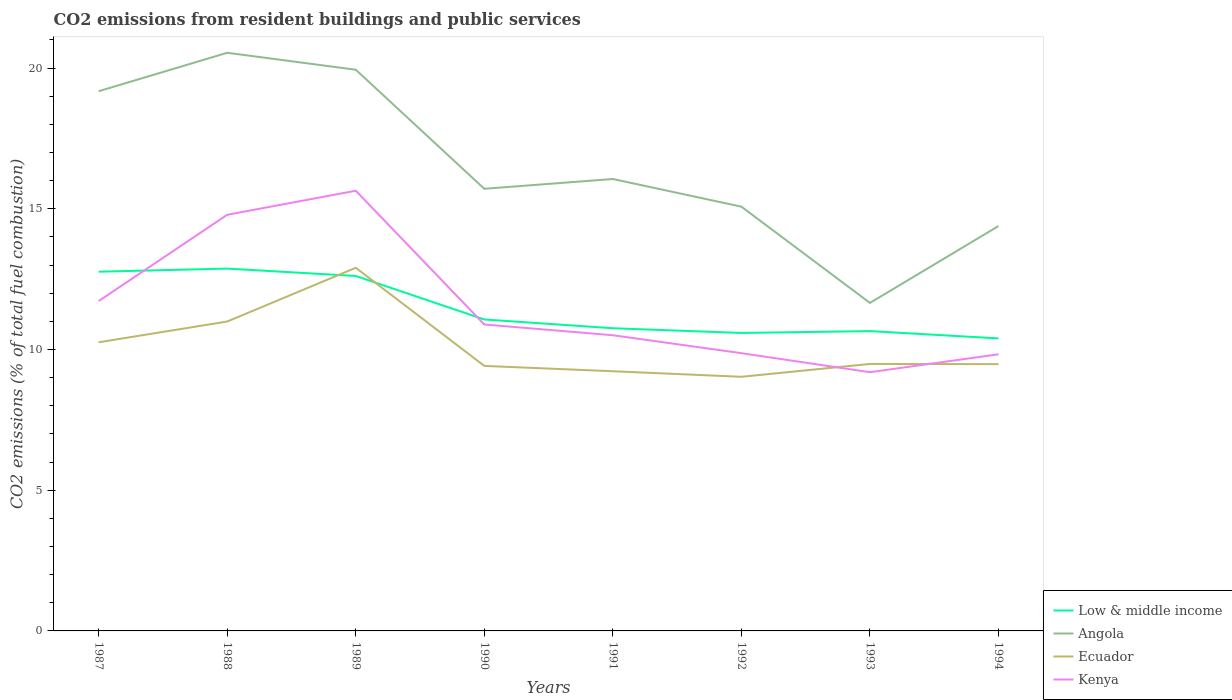How many different coloured lines are there?
Your answer should be compact. 4. Is the number of lines equal to the number of legend labels?
Your answer should be very brief. Yes. Across all years, what is the maximum total CO2 emitted in Low & middle income?
Give a very brief answer. 10.39. In which year was the total CO2 emitted in Kenya maximum?
Provide a succinct answer. 1993. What is the total total CO2 emitted in Kenya in the graph?
Provide a succinct answer. -3.07. What is the difference between the highest and the second highest total CO2 emitted in Kenya?
Your answer should be compact. 6.45. What is the difference between the highest and the lowest total CO2 emitted in Low & middle income?
Offer a very short reply. 3. How many years are there in the graph?
Make the answer very short. 8. What is the difference between two consecutive major ticks on the Y-axis?
Provide a succinct answer. 5. Where does the legend appear in the graph?
Give a very brief answer. Bottom right. What is the title of the graph?
Provide a succinct answer. CO2 emissions from resident buildings and public services. Does "Namibia" appear as one of the legend labels in the graph?
Provide a succinct answer. No. What is the label or title of the Y-axis?
Provide a succinct answer. CO2 emissions (% of total fuel combustion). What is the CO2 emissions (% of total fuel combustion) of Low & middle income in 1987?
Give a very brief answer. 12.76. What is the CO2 emissions (% of total fuel combustion) in Angola in 1987?
Your answer should be very brief. 19.18. What is the CO2 emissions (% of total fuel combustion) in Ecuador in 1987?
Make the answer very short. 10.26. What is the CO2 emissions (% of total fuel combustion) of Kenya in 1987?
Your answer should be compact. 11.72. What is the CO2 emissions (% of total fuel combustion) of Low & middle income in 1988?
Offer a very short reply. 12.88. What is the CO2 emissions (% of total fuel combustion) in Angola in 1988?
Your answer should be very brief. 20.54. What is the CO2 emissions (% of total fuel combustion) in Ecuador in 1988?
Your response must be concise. 10.99. What is the CO2 emissions (% of total fuel combustion) of Kenya in 1988?
Your response must be concise. 14.79. What is the CO2 emissions (% of total fuel combustion) in Low & middle income in 1989?
Your answer should be compact. 12.61. What is the CO2 emissions (% of total fuel combustion) in Angola in 1989?
Offer a terse response. 19.94. What is the CO2 emissions (% of total fuel combustion) of Ecuador in 1989?
Ensure brevity in your answer.  12.9. What is the CO2 emissions (% of total fuel combustion) in Kenya in 1989?
Give a very brief answer. 15.64. What is the CO2 emissions (% of total fuel combustion) of Low & middle income in 1990?
Your response must be concise. 11.07. What is the CO2 emissions (% of total fuel combustion) of Angola in 1990?
Provide a short and direct response. 15.71. What is the CO2 emissions (% of total fuel combustion) of Ecuador in 1990?
Ensure brevity in your answer.  9.42. What is the CO2 emissions (% of total fuel combustion) of Kenya in 1990?
Offer a terse response. 10.89. What is the CO2 emissions (% of total fuel combustion) in Low & middle income in 1991?
Give a very brief answer. 10.76. What is the CO2 emissions (% of total fuel combustion) of Angola in 1991?
Keep it short and to the point. 16.06. What is the CO2 emissions (% of total fuel combustion) in Ecuador in 1991?
Your answer should be very brief. 9.23. What is the CO2 emissions (% of total fuel combustion) of Kenya in 1991?
Give a very brief answer. 10.51. What is the CO2 emissions (% of total fuel combustion) of Low & middle income in 1992?
Keep it short and to the point. 10.59. What is the CO2 emissions (% of total fuel combustion) in Angola in 1992?
Make the answer very short. 15.08. What is the CO2 emissions (% of total fuel combustion) of Ecuador in 1992?
Your response must be concise. 9.03. What is the CO2 emissions (% of total fuel combustion) of Kenya in 1992?
Ensure brevity in your answer.  9.87. What is the CO2 emissions (% of total fuel combustion) of Low & middle income in 1993?
Provide a short and direct response. 10.65. What is the CO2 emissions (% of total fuel combustion) of Angola in 1993?
Ensure brevity in your answer.  11.66. What is the CO2 emissions (% of total fuel combustion) in Ecuador in 1993?
Keep it short and to the point. 9.49. What is the CO2 emissions (% of total fuel combustion) in Kenya in 1993?
Ensure brevity in your answer.  9.19. What is the CO2 emissions (% of total fuel combustion) of Low & middle income in 1994?
Make the answer very short. 10.39. What is the CO2 emissions (% of total fuel combustion) of Angola in 1994?
Offer a terse response. 14.39. What is the CO2 emissions (% of total fuel combustion) of Ecuador in 1994?
Provide a short and direct response. 9.48. What is the CO2 emissions (% of total fuel combustion) in Kenya in 1994?
Offer a very short reply. 9.83. Across all years, what is the maximum CO2 emissions (% of total fuel combustion) in Low & middle income?
Give a very brief answer. 12.88. Across all years, what is the maximum CO2 emissions (% of total fuel combustion) of Angola?
Your answer should be very brief. 20.54. Across all years, what is the maximum CO2 emissions (% of total fuel combustion) of Ecuador?
Your answer should be compact. 12.9. Across all years, what is the maximum CO2 emissions (% of total fuel combustion) in Kenya?
Provide a succinct answer. 15.64. Across all years, what is the minimum CO2 emissions (% of total fuel combustion) of Low & middle income?
Your answer should be very brief. 10.39. Across all years, what is the minimum CO2 emissions (% of total fuel combustion) in Angola?
Offer a terse response. 11.66. Across all years, what is the minimum CO2 emissions (% of total fuel combustion) in Ecuador?
Your answer should be very brief. 9.03. Across all years, what is the minimum CO2 emissions (% of total fuel combustion) in Kenya?
Offer a terse response. 9.19. What is the total CO2 emissions (% of total fuel combustion) of Low & middle income in the graph?
Your answer should be very brief. 91.71. What is the total CO2 emissions (% of total fuel combustion) of Angola in the graph?
Give a very brief answer. 132.55. What is the total CO2 emissions (% of total fuel combustion) of Ecuador in the graph?
Give a very brief answer. 80.8. What is the total CO2 emissions (% of total fuel combustion) in Kenya in the graph?
Give a very brief answer. 92.44. What is the difference between the CO2 emissions (% of total fuel combustion) in Low & middle income in 1987 and that in 1988?
Ensure brevity in your answer.  -0.11. What is the difference between the CO2 emissions (% of total fuel combustion) in Angola in 1987 and that in 1988?
Give a very brief answer. -1.37. What is the difference between the CO2 emissions (% of total fuel combustion) of Ecuador in 1987 and that in 1988?
Make the answer very short. -0.74. What is the difference between the CO2 emissions (% of total fuel combustion) of Kenya in 1987 and that in 1988?
Your answer should be compact. -3.07. What is the difference between the CO2 emissions (% of total fuel combustion) in Low & middle income in 1987 and that in 1989?
Offer a very short reply. 0.15. What is the difference between the CO2 emissions (% of total fuel combustion) in Angola in 1987 and that in 1989?
Ensure brevity in your answer.  -0.76. What is the difference between the CO2 emissions (% of total fuel combustion) of Ecuador in 1987 and that in 1989?
Your answer should be very brief. -2.65. What is the difference between the CO2 emissions (% of total fuel combustion) of Kenya in 1987 and that in 1989?
Ensure brevity in your answer.  -3.92. What is the difference between the CO2 emissions (% of total fuel combustion) in Low & middle income in 1987 and that in 1990?
Give a very brief answer. 1.7. What is the difference between the CO2 emissions (% of total fuel combustion) of Angola in 1987 and that in 1990?
Ensure brevity in your answer.  3.47. What is the difference between the CO2 emissions (% of total fuel combustion) in Ecuador in 1987 and that in 1990?
Give a very brief answer. 0.84. What is the difference between the CO2 emissions (% of total fuel combustion) in Kenya in 1987 and that in 1990?
Keep it short and to the point. 0.83. What is the difference between the CO2 emissions (% of total fuel combustion) of Low & middle income in 1987 and that in 1991?
Give a very brief answer. 2.01. What is the difference between the CO2 emissions (% of total fuel combustion) of Angola in 1987 and that in 1991?
Ensure brevity in your answer.  3.12. What is the difference between the CO2 emissions (% of total fuel combustion) of Ecuador in 1987 and that in 1991?
Keep it short and to the point. 1.03. What is the difference between the CO2 emissions (% of total fuel combustion) in Kenya in 1987 and that in 1991?
Offer a terse response. 1.22. What is the difference between the CO2 emissions (% of total fuel combustion) in Low & middle income in 1987 and that in 1992?
Make the answer very short. 2.18. What is the difference between the CO2 emissions (% of total fuel combustion) of Angola in 1987 and that in 1992?
Your response must be concise. 4.1. What is the difference between the CO2 emissions (% of total fuel combustion) in Ecuador in 1987 and that in 1992?
Your response must be concise. 1.23. What is the difference between the CO2 emissions (% of total fuel combustion) in Kenya in 1987 and that in 1992?
Your response must be concise. 1.85. What is the difference between the CO2 emissions (% of total fuel combustion) in Low & middle income in 1987 and that in 1993?
Your answer should be very brief. 2.11. What is the difference between the CO2 emissions (% of total fuel combustion) in Angola in 1987 and that in 1993?
Offer a very short reply. 7.52. What is the difference between the CO2 emissions (% of total fuel combustion) in Ecuador in 1987 and that in 1993?
Give a very brief answer. 0.77. What is the difference between the CO2 emissions (% of total fuel combustion) in Kenya in 1987 and that in 1993?
Your answer should be compact. 2.53. What is the difference between the CO2 emissions (% of total fuel combustion) of Low & middle income in 1987 and that in 1994?
Offer a terse response. 2.37. What is the difference between the CO2 emissions (% of total fuel combustion) in Angola in 1987 and that in 1994?
Keep it short and to the point. 4.79. What is the difference between the CO2 emissions (% of total fuel combustion) of Ecuador in 1987 and that in 1994?
Offer a very short reply. 0.78. What is the difference between the CO2 emissions (% of total fuel combustion) in Kenya in 1987 and that in 1994?
Offer a terse response. 1.89. What is the difference between the CO2 emissions (% of total fuel combustion) of Low & middle income in 1988 and that in 1989?
Offer a very short reply. 0.26. What is the difference between the CO2 emissions (% of total fuel combustion) of Angola in 1988 and that in 1989?
Offer a terse response. 0.6. What is the difference between the CO2 emissions (% of total fuel combustion) of Ecuador in 1988 and that in 1989?
Keep it short and to the point. -1.91. What is the difference between the CO2 emissions (% of total fuel combustion) in Kenya in 1988 and that in 1989?
Provide a succinct answer. -0.85. What is the difference between the CO2 emissions (% of total fuel combustion) in Low & middle income in 1988 and that in 1990?
Your response must be concise. 1.81. What is the difference between the CO2 emissions (% of total fuel combustion) in Angola in 1988 and that in 1990?
Your answer should be compact. 4.83. What is the difference between the CO2 emissions (% of total fuel combustion) of Ecuador in 1988 and that in 1990?
Your response must be concise. 1.58. What is the difference between the CO2 emissions (% of total fuel combustion) in Kenya in 1988 and that in 1990?
Provide a succinct answer. 3.9. What is the difference between the CO2 emissions (% of total fuel combustion) in Low & middle income in 1988 and that in 1991?
Your answer should be compact. 2.12. What is the difference between the CO2 emissions (% of total fuel combustion) in Angola in 1988 and that in 1991?
Give a very brief answer. 4.49. What is the difference between the CO2 emissions (% of total fuel combustion) in Ecuador in 1988 and that in 1991?
Make the answer very short. 1.77. What is the difference between the CO2 emissions (% of total fuel combustion) of Kenya in 1988 and that in 1991?
Offer a very short reply. 4.28. What is the difference between the CO2 emissions (% of total fuel combustion) of Low & middle income in 1988 and that in 1992?
Provide a short and direct response. 2.29. What is the difference between the CO2 emissions (% of total fuel combustion) in Angola in 1988 and that in 1992?
Make the answer very short. 5.47. What is the difference between the CO2 emissions (% of total fuel combustion) of Ecuador in 1988 and that in 1992?
Your answer should be very brief. 1.96. What is the difference between the CO2 emissions (% of total fuel combustion) in Kenya in 1988 and that in 1992?
Offer a terse response. 4.92. What is the difference between the CO2 emissions (% of total fuel combustion) in Low & middle income in 1988 and that in 1993?
Offer a very short reply. 2.22. What is the difference between the CO2 emissions (% of total fuel combustion) of Angola in 1988 and that in 1993?
Give a very brief answer. 8.89. What is the difference between the CO2 emissions (% of total fuel combustion) of Ecuador in 1988 and that in 1993?
Provide a succinct answer. 1.51. What is the difference between the CO2 emissions (% of total fuel combustion) of Kenya in 1988 and that in 1993?
Your answer should be very brief. 5.59. What is the difference between the CO2 emissions (% of total fuel combustion) of Low & middle income in 1988 and that in 1994?
Offer a very short reply. 2.48. What is the difference between the CO2 emissions (% of total fuel combustion) in Angola in 1988 and that in 1994?
Offer a terse response. 6.16. What is the difference between the CO2 emissions (% of total fuel combustion) in Ecuador in 1988 and that in 1994?
Offer a very short reply. 1.51. What is the difference between the CO2 emissions (% of total fuel combustion) in Kenya in 1988 and that in 1994?
Ensure brevity in your answer.  4.96. What is the difference between the CO2 emissions (% of total fuel combustion) of Low & middle income in 1989 and that in 1990?
Ensure brevity in your answer.  1.55. What is the difference between the CO2 emissions (% of total fuel combustion) in Angola in 1989 and that in 1990?
Your response must be concise. 4.23. What is the difference between the CO2 emissions (% of total fuel combustion) in Ecuador in 1989 and that in 1990?
Keep it short and to the point. 3.49. What is the difference between the CO2 emissions (% of total fuel combustion) in Kenya in 1989 and that in 1990?
Keep it short and to the point. 4.75. What is the difference between the CO2 emissions (% of total fuel combustion) of Low & middle income in 1989 and that in 1991?
Make the answer very short. 1.86. What is the difference between the CO2 emissions (% of total fuel combustion) in Angola in 1989 and that in 1991?
Provide a short and direct response. 3.88. What is the difference between the CO2 emissions (% of total fuel combustion) in Ecuador in 1989 and that in 1991?
Keep it short and to the point. 3.68. What is the difference between the CO2 emissions (% of total fuel combustion) in Kenya in 1989 and that in 1991?
Offer a very short reply. 5.13. What is the difference between the CO2 emissions (% of total fuel combustion) in Low & middle income in 1989 and that in 1992?
Ensure brevity in your answer.  2.02. What is the difference between the CO2 emissions (% of total fuel combustion) in Angola in 1989 and that in 1992?
Your answer should be very brief. 4.87. What is the difference between the CO2 emissions (% of total fuel combustion) of Ecuador in 1989 and that in 1992?
Provide a short and direct response. 3.87. What is the difference between the CO2 emissions (% of total fuel combustion) of Kenya in 1989 and that in 1992?
Provide a succinct answer. 5.77. What is the difference between the CO2 emissions (% of total fuel combustion) in Low & middle income in 1989 and that in 1993?
Your answer should be compact. 1.96. What is the difference between the CO2 emissions (% of total fuel combustion) in Angola in 1989 and that in 1993?
Provide a succinct answer. 8.29. What is the difference between the CO2 emissions (% of total fuel combustion) in Ecuador in 1989 and that in 1993?
Provide a short and direct response. 3.42. What is the difference between the CO2 emissions (% of total fuel combustion) of Kenya in 1989 and that in 1993?
Your answer should be very brief. 6.45. What is the difference between the CO2 emissions (% of total fuel combustion) of Low & middle income in 1989 and that in 1994?
Your answer should be very brief. 2.22. What is the difference between the CO2 emissions (% of total fuel combustion) of Angola in 1989 and that in 1994?
Offer a very short reply. 5.55. What is the difference between the CO2 emissions (% of total fuel combustion) in Ecuador in 1989 and that in 1994?
Keep it short and to the point. 3.42. What is the difference between the CO2 emissions (% of total fuel combustion) in Kenya in 1989 and that in 1994?
Provide a short and direct response. 5.81. What is the difference between the CO2 emissions (% of total fuel combustion) of Low & middle income in 1990 and that in 1991?
Offer a very short reply. 0.31. What is the difference between the CO2 emissions (% of total fuel combustion) in Angola in 1990 and that in 1991?
Ensure brevity in your answer.  -0.35. What is the difference between the CO2 emissions (% of total fuel combustion) of Ecuador in 1990 and that in 1991?
Your response must be concise. 0.19. What is the difference between the CO2 emissions (% of total fuel combustion) of Kenya in 1990 and that in 1991?
Ensure brevity in your answer.  0.38. What is the difference between the CO2 emissions (% of total fuel combustion) in Low & middle income in 1990 and that in 1992?
Your answer should be very brief. 0.48. What is the difference between the CO2 emissions (% of total fuel combustion) of Angola in 1990 and that in 1992?
Your answer should be compact. 0.64. What is the difference between the CO2 emissions (% of total fuel combustion) in Ecuador in 1990 and that in 1992?
Offer a terse response. 0.39. What is the difference between the CO2 emissions (% of total fuel combustion) of Kenya in 1990 and that in 1992?
Offer a terse response. 1.02. What is the difference between the CO2 emissions (% of total fuel combustion) in Low & middle income in 1990 and that in 1993?
Your answer should be very brief. 0.41. What is the difference between the CO2 emissions (% of total fuel combustion) in Angola in 1990 and that in 1993?
Your answer should be very brief. 4.06. What is the difference between the CO2 emissions (% of total fuel combustion) in Ecuador in 1990 and that in 1993?
Your answer should be compact. -0.07. What is the difference between the CO2 emissions (% of total fuel combustion) of Kenya in 1990 and that in 1993?
Your response must be concise. 1.7. What is the difference between the CO2 emissions (% of total fuel combustion) in Low & middle income in 1990 and that in 1994?
Provide a short and direct response. 0.67. What is the difference between the CO2 emissions (% of total fuel combustion) in Angola in 1990 and that in 1994?
Provide a short and direct response. 1.32. What is the difference between the CO2 emissions (% of total fuel combustion) in Ecuador in 1990 and that in 1994?
Provide a short and direct response. -0.06. What is the difference between the CO2 emissions (% of total fuel combustion) of Kenya in 1990 and that in 1994?
Your answer should be compact. 1.06. What is the difference between the CO2 emissions (% of total fuel combustion) in Low & middle income in 1991 and that in 1992?
Provide a short and direct response. 0.17. What is the difference between the CO2 emissions (% of total fuel combustion) in Ecuador in 1991 and that in 1992?
Offer a terse response. 0.2. What is the difference between the CO2 emissions (% of total fuel combustion) of Kenya in 1991 and that in 1992?
Your answer should be compact. 0.64. What is the difference between the CO2 emissions (% of total fuel combustion) in Low & middle income in 1991 and that in 1993?
Give a very brief answer. 0.1. What is the difference between the CO2 emissions (% of total fuel combustion) of Angola in 1991 and that in 1993?
Your answer should be compact. 4.4. What is the difference between the CO2 emissions (% of total fuel combustion) in Ecuador in 1991 and that in 1993?
Your answer should be very brief. -0.26. What is the difference between the CO2 emissions (% of total fuel combustion) in Kenya in 1991 and that in 1993?
Provide a short and direct response. 1.31. What is the difference between the CO2 emissions (% of total fuel combustion) in Low & middle income in 1991 and that in 1994?
Provide a short and direct response. 0.36. What is the difference between the CO2 emissions (% of total fuel combustion) of Angola in 1991 and that in 1994?
Your answer should be compact. 1.67. What is the difference between the CO2 emissions (% of total fuel combustion) of Ecuador in 1991 and that in 1994?
Offer a terse response. -0.25. What is the difference between the CO2 emissions (% of total fuel combustion) in Kenya in 1991 and that in 1994?
Make the answer very short. 0.68. What is the difference between the CO2 emissions (% of total fuel combustion) of Low & middle income in 1992 and that in 1993?
Make the answer very short. -0.07. What is the difference between the CO2 emissions (% of total fuel combustion) in Angola in 1992 and that in 1993?
Keep it short and to the point. 3.42. What is the difference between the CO2 emissions (% of total fuel combustion) of Ecuador in 1992 and that in 1993?
Give a very brief answer. -0.46. What is the difference between the CO2 emissions (% of total fuel combustion) of Kenya in 1992 and that in 1993?
Your answer should be very brief. 0.68. What is the difference between the CO2 emissions (% of total fuel combustion) in Low & middle income in 1992 and that in 1994?
Keep it short and to the point. 0.19. What is the difference between the CO2 emissions (% of total fuel combustion) in Angola in 1992 and that in 1994?
Your response must be concise. 0.69. What is the difference between the CO2 emissions (% of total fuel combustion) in Ecuador in 1992 and that in 1994?
Offer a very short reply. -0.45. What is the difference between the CO2 emissions (% of total fuel combustion) of Kenya in 1992 and that in 1994?
Your answer should be compact. 0.04. What is the difference between the CO2 emissions (% of total fuel combustion) in Low & middle income in 1993 and that in 1994?
Keep it short and to the point. 0.26. What is the difference between the CO2 emissions (% of total fuel combustion) of Angola in 1993 and that in 1994?
Your answer should be compact. -2.73. What is the difference between the CO2 emissions (% of total fuel combustion) in Ecuador in 1993 and that in 1994?
Your answer should be compact. 0.01. What is the difference between the CO2 emissions (% of total fuel combustion) of Kenya in 1993 and that in 1994?
Offer a very short reply. -0.64. What is the difference between the CO2 emissions (% of total fuel combustion) in Low & middle income in 1987 and the CO2 emissions (% of total fuel combustion) in Angola in 1988?
Your response must be concise. -7.78. What is the difference between the CO2 emissions (% of total fuel combustion) of Low & middle income in 1987 and the CO2 emissions (% of total fuel combustion) of Ecuador in 1988?
Your answer should be very brief. 1.77. What is the difference between the CO2 emissions (% of total fuel combustion) in Low & middle income in 1987 and the CO2 emissions (% of total fuel combustion) in Kenya in 1988?
Provide a succinct answer. -2.02. What is the difference between the CO2 emissions (% of total fuel combustion) in Angola in 1987 and the CO2 emissions (% of total fuel combustion) in Ecuador in 1988?
Offer a very short reply. 8.18. What is the difference between the CO2 emissions (% of total fuel combustion) of Angola in 1987 and the CO2 emissions (% of total fuel combustion) of Kenya in 1988?
Provide a short and direct response. 4.39. What is the difference between the CO2 emissions (% of total fuel combustion) in Ecuador in 1987 and the CO2 emissions (% of total fuel combustion) in Kenya in 1988?
Keep it short and to the point. -4.53. What is the difference between the CO2 emissions (% of total fuel combustion) of Low & middle income in 1987 and the CO2 emissions (% of total fuel combustion) of Angola in 1989?
Your answer should be compact. -7.18. What is the difference between the CO2 emissions (% of total fuel combustion) of Low & middle income in 1987 and the CO2 emissions (% of total fuel combustion) of Ecuador in 1989?
Give a very brief answer. -0.14. What is the difference between the CO2 emissions (% of total fuel combustion) in Low & middle income in 1987 and the CO2 emissions (% of total fuel combustion) in Kenya in 1989?
Make the answer very short. -2.88. What is the difference between the CO2 emissions (% of total fuel combustion) in Angola in 1987 and the CO2 emissions (% of total fuel combustion) in Ecuador in 1989?
Ensure brevity in your answer.  6.27. What is the difference between the CO2 emissions (% of total fuel combustion) of Angola in 1987 and the CO2 emissions (% of total fuel combustion) of Kenya in 1989?
Your answer should be very brief. 3.54. What is the difference between the CO2 emissions (% of total fuel combustion) of Ecuador in 1987 and the CO2 emissions (% of total fuel combustion) of Kenya in 1989?
Make the answer very short. -5.39. What is the difference between the CO2 emissions (% of total fuel combustion) of Low & middle income in 1987 and the CO2 emissions (% of total fuel combustion) of Angola in 1990?
Keep it short and to the point. -2.95. What is the difference between the CO2 emissions (% of total fuel combustion) of Low & middle income in 1987 and the CO2 emissions (% of total fuel combustion) of Ecuador in 1990?
Offer a terse response. 3.35. What is the difference between the CO2 emissions (% of total fuel combustion) of Low & middle income in 1987 and the CO2 emissions (% of total fuel combustion) of Kenya in 1990?
Make the answer very short. 1.88. What is the difference between the CO2 emissions (% of total fuel combustion) of Angola in 1987 and the CO2 emissions (% of total fuel combustion) of Ecuador in 1990?
Offer a very short reply. 9.76. What is the difference between the CO2 emissions (% of total fuel combustion) of Angola in 1987 and the CO2 emissions (% of total fuel combustion) of Kenya in 1990?
Provide a short and direct response. 8.29. What is the difference between the CO2 emissions (% of total fuel combustion) in Ecuador in 1987 and the CO2 emissions (% of total fuel combustion) in Kenya in 1990?
Keep it short and to the point. -0.63. What is the difference between the CO2 emissions (% of total fuel combustion) in Low & middle income in 1987 and the CO2 emissions (% of total fuel combustion) in Angola in 1991?
Offer a terse response. -3.29. What is the difference between the CO2 emissions (% of total fuel combustion) in Low & middle income in 1987 and the CO2 emissions (% of total fuel combustion) in Ecuador in 1991?
Offer a very short reply. 3.54. What is the difference between the CO2 emissions (% of total fuel combustion) in Low & middle income in 1987 and the CO2 emissions (% of total fuel combustion) in Kenya in 1991?
Provide a succinct answer. 2.26. What is the difference between the CO2 emissions (% of total fuel combustion) of Angola in 1987 and the CO2 emissions (% of total fuel combustion) of Ecuador in 1991?
Provide a succinct answer. 9.95. What is the difference between the CO2 emissions (% of total fuel combustion) of Angola in 1987 and the CO2 emissions (% of total fuel combustion) of Kenya in 1991?
Keep it short and to the point. 8.67. What is the difference between the CO2 emissions (% of total fuel combustion) of Ecuador in 1987 and the CO2 emissions (% of total fuel combustion) of Kenya in 1991?
Provide a short and direct response. -0.25. What is the difference between the CO2 emissions (% of total fuel combustion) in Low & middle income in 1987 and the CO2 emissions (% of total fuel combustion) in Angola in 1992?
Your answer should be compact. -2.31. What is the difference between the CO2 emissions (% of total fuel combustion) of Low & middle income in 1987 and the CO2 emissions (% of total fuel combustion) of Ecuador in 1992?
Provide a short and direct response. 3.73. What is the difference between the CO2 emissions (% of total fuel combustion) of Low & middle income in 1987 and the CO2 emissions (% of total fuel combustion) of Kenya in 1992?
Your response must be concise. 2.9. What is the difference between the CO2 emissions (% of total fuel combustion) of Angola in 1987 and the CO2 emissions (% of total fuel combustion) of Ecuador in 1992?
Offer a terse response. 10.15. What is the difference between the CO2 emissions (% of total fuel combustion) in Angola in 1987 and the CO2 emissions (% of total fuel combustion) in Kenya in 1992?
Keep it short and to the point. 9.31. What is the difference between the CO2 emissions (% of total fuel combustion) of Ecuador in 1987 and the CO2 emissions (% of total fuel combustion) of Kenya in 1992?
Provide a succinct answer. 0.39. What is the difference between the CO2 emissions (% of total fuel combustion) of Low & middle income in 1987 and the CO2 emissions (% of total fuel combustion) of Angola in 1993?
Provide a short and direct response. 1.11. What is the difference between the CO2 emissions (% of total fuel combustion) in Low & middle income in 1987 and the CO2 emissions (% of total fuel combustion) in Ecuador in 1993?
Your response must be concise. 3.28. What is the difference between the CO2 emissions (% of total fuel combustion) in Low & middle income in 1987 and the CO2 emissions (% of total fuel combustion) in Kenya in 1993?
Offer a terse response. 3.57. What is the difference between the CO2 emissions (% of total fuel combustion) in Angola in 1987 and the CO2 emissions (% of total fuel combustion) in Ecuador in 1993?
Your response must be concise. 9.69. What is the difference between the CO2 emissions (% of total fuel combustion) of Angola in 1987 and the CO2 emissions (% of total fuel combustion) of Kenya in 1993?
Make the answer very short. 9.98. What is the difference between the CO2 emissions (% of total fuel combustion) of Ecuador in 1987 and the CO2 emissions (% of total fuel combustion) of Kenya in 1993?
Offer a terse response. 1.06. What is the difference between the CO2 emissions (% of total fuel combustion) of Low & middle income in 1987 and the CO2 emissions (% of total fuel combustion) of Angola in 1994?
Keep it short and to the point. -1.62. What is the difference between the CO2 emissions (% of total fuel combustion) in Low & middle income in 1987 and the CO2 emissions (% of total fuel combustion) in Ecuador in 1994?
Keep it short and to the point. 3.28. What is the difference between the CO2 emissions (% of total fuel combustion) of Low & middle income in 1987 and the CO2 emissions (% of total fuel combustion) of Kenya in 1994?
Your answer should be compact. 2.93. What is the difference between the CO2 emissions (% of total fuel combustion) in Angola in 1987 and the CO2 emissions (% of total fuel combustion) in Ecuador in 1994?
Your answer should be compact. 9.7. What is the difference between the CO2 emissions (% of total fuel combustion) of Angola in 1987 and the CO2 emissions (% of total fuel combustion) of Kenya in 1994?
Give a very brief answer. 9.35. What is the difference between the CO2 emissions (% of total fuel combustion) of Ecuador in 1987 and the CO2 emissions (% of total fuel combustion) of Kenya in 1994?
Give a very brief answer. 0.43. What is the difference between the CO2 emissions (% of total fuel combustion) of Low & middle income in 1988 and the CO2 emissions (% of total fuel combustion) of Angola in 1989?
Give a very brief answer. -7.07. What is the difference between the CO2 emissions (% of total fuel combustion) of Low & middle income in 1988 and the CO2 emissions (% of total fuel combustion) of Ecuador in 1989?
Keep it short and to the point. -0.03. What is the difference between the CO2 emissions (% of total fuel combustion) of Low & middle income in 1988 and the CO2 emissions (% of total fuel combustion) of Kenya in 1989?
Your response must be concise. -2.77. What is the difference between the CO2 emissions (% of total fuel combustion) in Angola in 1988 and the CO2 emissions (% of total fuel combustion) in Ecuador in 1989?
Your response must be concise. 7.64. What is the difference between the CO2 emissions (% of total fuel combustion) of Angola in 1988 and the CO2 emissions (% of total fuel combustion) of Kenya in 1989?
Your answer should be very brief. 4.9. What is the difference between the CO2 emissions (% of total fuel combustion) of Ecuador in 1988 and the CO2 emissions (% of total fuel combustion) of Kenya in 1989?
Keep it short and to the point. -4.65. What is the difference between the CO2 emissions (% of total fuel combustion) of Low & middle income in 1988 and the CO2 emissions (% of total fuel combustion) of Angola in 1990?
Provide a succinct answer. -2.84. What is the difference between the CO2 emissions (% of total fuel combustion) in Low & middle income in 1988 and the CO2 emissions (% of total fuel combustion) in Ecuador in 1990?
Offer a very short reply. 3.46. What is the difference between the CO2 emissions (% of total fuel combustion) of Low & middle income in 1988 and the CO2 emissions (% of total fuel combustion) of Kenya in 1990?
Provide a succinct answer. 1.99. What is the difference between the CO2 emissions (% of total fuel combustion) in Angola in 1988 and the CO2 emissions (% of total fuel combustion) in Ecuador in 1990?
Provide a short and direct response. 11.13. What is the difference between the CO2 emissions (% of total fuel combustion) in Angola in 1988 and the CO2 emissions (% of total fuel combustion) in Kenya in 1990?
Your answer should be very brief. 9.65. What is the difference between the CO2 emissions (% of total fuel combustion) in Ecuador in 1988 and the CO2 emissions (% of total fuel combustion) in Kenya in 1990?
Your answer should be very brief. 0.1. What is the difference between the CO2 emissions (% of total fuel combustion) of Low & middle income in 1988 and the CO2 emissions (% of total fuel combustion) of Angola in 1991?
Make the answer very short. -3.18. What is the difference between the CO2 emissions (% of total fuel combustion) of Low & middle income in 1988 and the CO2 emissions (% of total fuel combustion) of Ecuador in 1991?
Make the answer very short. 3.65. What is the difference between the CO2 emissions (% of total fuel combustion) of Low & middle income in 1988 and the CO2 emissions (% of total fuel combustion) of Kenya in 1991?
Keep it short and to the point. 2.37. What is the difference between the CO2 emissions (% of total fuel combustion) in Angola in 1988 and the CO2 emissions (% of total fuel combustion) in Ecuador in 1991?
Your answer should be compact. 11.32. What is the difference between the CO2 emissions (% of total fuel combustion) in Angola in 1988 and the CO2 emissions (% of total fuel combustion) in Kenya in 1991?
Give a very brief answer. 10.04. What is the difference between the CO2 emissions (% of total fuel combustion) in Ecuador in 1988 and the CO2 emissions (% of total fuel combustion) in Kenya in 1991?
Make the answer very short. 0.49. What is the difference between the CO2 emissions (% of total fuel combustion) in Low & middle income in 1988 and the CO2 emissions (% of total fuel combustion) in Angola in 1992?
Your answer should be compact. -2.2. What is the difference between the CO2 emissions (% of total fuel combustion) in Low & middle income in 1988 and the CO2 emissions (% of total fuel combustion) in Ecuador in 1992?
Keep it short and to the point. 3.84. What is the difference between the CO2 emissions (% of total fuel combustion) of Low & middle income in 1988 and the CO2 emissions (% of total fuel combustion) of Kenya in 1992?
Offer a terse response. 3.01. What is the difference between the CO2 emissions (% of total fuel combustion) of Angola in 1988 and the CO2 emissions (% of total fuel combustion) of Ecuador in 1992?
Provide a succinct answer. 11.51. What is the difference between the CO2 emissions (% of total fuel combustion) of Angola in 1988 and the CO2 emissions (% of total fuel combustion) of Kenya in 1992?
Your answer should be very brief. 10.67. What is the difference between the CO2 emissions (% of total fuel combustion) of Ecuador in 1988 and the CO2 emissions (% of total fuel combustion) of Kenya in 1992?
Give a very brief answer. 1.12. What is the difference between the CO2 emissions (% of total fuel combustion) of Low & middle income in 1988 and the CO2 emissions (% of total fuel combustion) of Angola in 1993?
Make the answer very short. 1.22. What is the difference between the CO2 emissions (% of total fuel combustion) in Low & middle income in 1988 and the CO2 emissions (% of total fuel combustion) in Ecuador in 1993?
Your answer should be very brief. 3.39. What is the difference between the CO2 emissions (% of total fuel combustion) of Low & middle income in 1988 and the CO2 emissions (% of total fuel combustion) of Kenya in 1993?
Provide a short and direct response. 3.68. What is the difference between the CO2 emissions (% of total fuel combustion) in Angola in 1988 and the CO2 emissions (% of total fuel combustion) in Ecuador in 1993?
Ensure brevity in your answer.  11.06. What is the difference between the CO2 emissions (% of total fuel combustion) of Angola in 1988 and the CO2 emissions (% of total fuel combustion) of Kenya in 1993?
Ensure brevity in your answer.  11.35. What is the difference between the CO2 emissions (% of total fuel combustion) of Ecuador in 1988 and the CO2 emissions (% of total fuel combustion) of Kenya in 1993?
Keep it short and to the point. 1.8. What is the difference between the CO2 emissions (% of total fuel combustion) in Low & middle income in 1988 and the CO2 emissions (% of total fuel combustion) in Angola in 1994?
Ensure brevity in your answer.  -1.51. What is the difference between the CO2 emissions (% of total fuel combustion) of Low & middle income in 1988 and the CO2 emissions (% of total fuel combustion) of Ecuador in 1994?
Give a very brief answer. 3.4. What is the difference between the CO2 emissions (% of total fuel combustion) of Low & middle income in 1988 and the CO2 emissions (% of total fuel combustion) of Kenya in 1994?
Keep it short and to the point. 3.05. What is the difference between the CO2 emissions (% of total fuel combustion) in Angola in 1988 and the CO2 emissions (% of total fuel combustion) in Ecuador in 1994?
Give a very brief answer. 11.06. What is the difference between the CO2 emissions (% of total fuel combustion) of Angola in 1988 and the CO2 emissions (% of total fuel combustion) of Kenya in 1994?
Your response must be concise. 10.71. What is the difference between the CO2 emissions (% of total fuel combustion) in Ecuador in 1988 and the CO2 emissions (% of total fuel combustion) in Kenya in 1994?
Make the answer very short. 1.16. What is the difference between the CO2 emissions (% of total fuel combustion) of Low & middle income in 1989 and the CO2 emissions (% of total fuel combustion) of Angola in 1990?
Your answer should be compact. -3.1. What is the difference between the CO2 emissions (% of total fuel combustion) in Low & middle income in 1989 and the CO2 emissions (% of total fuel combustion) in Ecuador in 1990?
Your answer should be compact. 3.2. What is the difference between the CO2 emissions (% of total fuel combustion) of Low & middle income in 1989 and the CO2 emissions (% of total fuel combustion) of Kenya in 1990?
Provide a succinct answer. 1.72. What is the difference between the CO2 emissions (% of total fuel combustion) in Angola in 1989 and the CO2 emissions (% of total fuel combustion) in Ecuador in 1990?
Your response must be concise. 10.52. What is the difference between the CO2 emissions (% of total fuel combustion) in Angola in 1989 and the CO2 emissions (% of total fuel combustion) in Kenya in 1990?
Make the answer very short. 9.05. What is the difference between the CO2 emissions (% of total fuel combustion) of Ecuador in 1989 and the CO2 emissions (% of total fuel combustion) of Kenya in 1990?
Offer a terse response. 2.01. What is the difference between the CO2 emissions (% of total fuel combustion) in Low & middle income in 1989 and the CO2 emissions (% of total fuel combustion) in Angola in 1991?
Provide a succinct answer. -3.45. What is the difference between the CO2 emissions (% of total fuel combustion) in Low & middle income in 1989 and the CO2 emissions (% of total fuel combustion) in Ecuador in 1991?
Provide a short and direct response. 3.38. What is the difference between the CO2 emissions (% of total fuel combustion) in Low & middle income in 1989 and the CO2 emissions (% of total fuel combustion) in Kenya in 1991?
Keep it short and to the point. 2.11. What is the difference between the CO2 emissions (% of total fuel combustion) in Angola in 1989 and the CO2 emissions (% of total fuel combustion) in Ecuador in 1991?
Your answer should be compact. 10.71. What is the difference between the CO2 emissions (% of total fuel combustion) in Angola in 1989 and the CO2 emissions (% of total fuel combustion) in Kenya in 1991?
Offer a very short reply. 9.43. What is the difference between the CO2 emissions (% of total fuel combustion) in Ecuador in 1989 and the CO2 emissions (% of total fuel combustion) in Kenya in 1991?
Keep it short and to the point. 2.4. What is the difference between the CO2 emissions (% of total fuel combustion) of Low & middle income in 1989 and the CO2 emissions (% of total fuel combustion) of Angola in 1992?
Ensure brevity in your answer.  -2.46. What is the difference between the CO2 emissions (% of total fuel combustion) of Low & middle income in 1989 and the CO2 emissions (% of total fuel combustion) of Ecuador in 1992?
Your response must be concise. 3.58. What is the difference between the CO2 emissions (% of total fuel combustion) of Low & middle income in 1989 and the CO2 emissions (% of total fuel combustion) of Kenya in 1992?
Offer a very short reply. 2.74. What is the difference between the CO2 emissions (% of total fuel combustion) in Angola in 1989 and the CO2 emissions (% of total fuel combustion) in Ecuador in 1992?
Offer a very short reply. 10.91. What is the difference between the CO2 emissions (% of total fuel combustion) in Angola in 1989 and the CO2 emissions (% of total fuel combustion) in Kenya in 1992?
Give a very brief answer. 10.07. What is the difference between the CO2 emissions (% of total fuel combustion) in Ecuador in 1989 and the CO2 emissions (% of total fuel combustion) in Kenya in 1992?
Offer a very short reply. 3.03. What is the difference between the CO2 emissions (% of total fuel combustion) of Low & middle income in 1989 and the CO2 emissions (% of total fuel combustion) of Angola in 1993?
Your answer should be compact. 0.96. What is the difference between the CO2 emissions (% of total fuel combustion) of Low & middle income in 1989 and the CO2 emissions (% of total fuel combustion) of Ecuador in 1993?
Make the answer very short. 3.13. What is the difference between the CO2 emissions (% of total fuel combustion) of Low & middle income in 1989 and the CO2 emissions (% of total fuel combustion) of Kenya in 1993?
Make the answer very short. 3.42. What is the difference between the CO2 emissions (% of total fuel combustion) of Angola in 1989 and the CO2 emissions (% of total fuel combustion) of Ecuador in 1993?
Provide a short and direct response. 10.45. What is the difference between the CO2 emissions (% of total fuel combustion) of Angola in 1989 and the CO2 emissions (% of total fuel combustion) of Kenya in 1993?
Make the answer very short. 10.75. What is the difference between the CO2 emissions (% of total fuel combustion) of Ecuador in 1989 and the CO2 emissions (% of total fuel combustion) of Kenya in 1993?
Your response must be concise. 3.71. What is the difference between the CO2 emissions (% of total fuel combustion) of Low & middle income in 1989 and the CO2 emissions (% of total fuel combustion) of Angola in 1994?
Provide a short and direct response. -1.77. What is the difference between the CO2 emissions (% of total fuel combustion) in Low & middle income in 1989 and the CO2 emissions (% of total fuel combustion) in Ecuador in 1994?
Provide a succinct answer. 3.13. What is the difference between the CO2 emissions (% of total fuel combustion) of Low & middle income in 1989 and the CO2 emissions (% of total fuel combustion) of Kenya in 1994?
Make the answer very short. 2.78. What is the difference between the CO2 emissions (% of total fuel combustion) in Angola in 1989 and the CO2 emissions (% of total fuel combustion) in Ecuador in 1994?
Your answer should be very brief. 10.46. What is the difference between the CO2 emissions (% of total fuel combustion) of Angola in 1989 and the CO2 emissions (% of total fuel combustion) of Kenya in 1994?
Your response must be concise. 10.11. What is the difference between the CO2 emissions (% of total fuel combustion) in Ecuador in 1989 and the CO2 emissions (% of total fuel combustion) in Kenya in 1994?
Provide a short and direct response. 3.07. What is the difference between the CO2 emissions (% of total fuel combustion) of Low & middle income in 1990 and the CO2 emissions (% of total fuel combustion) of Angola in 1991?
Your answer should be compact. -4.99. What is the difference between the CO2 emissions (% of total fuel combustion) in Low & middle income in 1990 and the CO2 emissions (% of total fuel combustion) in Ecuador in 1991?
Your response must be concise. 1.84. What is the difference between the CO2 emissions (% of total fuel combustion) in Low & middle income in 1990 and the CO2 emissions (% of total fuel combustion) in Kenya in 1991?
Ensure brevity in your answer.  0.56. What is the difference between the CO2 emissions (% of total fuel combustion) of Angola in 1990 and the CO2 emissions (% of total fuel combustion) of Ecuador in 1991?
Offer a very short reply. 6.48. What is the difference between the CO2 emissions (% of total fuel combustion) of Angola in 1990 and the CO2 emissions (% of total fuel combustion) of Kenya in 1991?
Offer a very short reply. 5.2. What is the difference between the CO2 emissions (% of total fuel combustion) in Ecuador in 1990 and the CO2 emissions (% of total fuel combustion) in Kenya in 1991?
Your answer should be compact. -1.09. What is the difference between the CO2 emissions (% of total fuel combustion) of Low & middle income in 1990 and the CO2 emissions (% of total fuel combustion) of Angola in 1992?
Offer a terse response. -4.01. What is the difference between the CO2 emissions (% of total fuel combustion) in Low & middle income in 1990 and the CO2 emissions (% of total fuel combustion) in Ecuador in 1992?
Your answer should be very brief. 2.04. What is the difference between the CO2 emissions (% of total fuel combustion) of Low & middle income in 1990 and the CO2 emissions (% of total fuel combustion) of Kenya in 1992?
Provide a short and direct response. 1.2. What is the difference between the CO2 emissions (% of total fuel combustion) in Angola in 1990 and the CO2 emissions (% of total fuel combustion) in Ecuador in 1992?
Offer a terse response. 6.68. What is the difference between the CO2 emissions (% of total fuel combustion) of Angola in 1990 and the CO2 emissions (% of total fuel combustion) of Kenya in 1992?
Your answer should be very brief. 5.84. What is the difference between the CO2 emissions (% of total fuel combustion) of Ecuador in 1990 and the CO2 emissions (% of total fuel combustion) of Kenya in 1992?
Provide a succinct answer. -0.45. What is the difference between the CO2 emissions (% of total fuel combustion) of Low & middle income in 1990 and the CO2 emissions (% of total fuel combustion) of Angola in 1993?
Your answer should be compact. -0.59. What is the difference between the CO2 emissions (% of total fuel combustion) in Low & middle income in 1990 and the CO2 emissions (% of total fuel combustion) in Ecuador in 1993?
Provide a short and direct response. 1.58. What is the difference between the CO2 emissions (% of total fuel combustion) in Low & middle income in 1990 and the CO2 emissions (% of total fuel combustion) in Kenya in 1993?
Make the answer very short. 1.87. What is the difference between the CO2 emissions (% of total fuel combustion) of Angola in 1990 and the CO2 emissions (% of total fuel combustion) of Ecuador in 1993?
Keep it short and to the point. 6.22. What is the difference between the CO2 emissions (% of total fuel combustion) in Angola in 1990 and the CO2 emissions (% of total fuel combustion) in Kenya in 1993?
Provide a succinct answer. 6.52. What is the difference between the CO2 emissions (% of total fuel combustion) of Ecuador in 1990 and the CO2 emissions (% of total fuel combustion) of Kenya in 1993?
Make the answer very short. 0.22. What is the difference between the CO2 emissions (% of total fuel combustion) of Low & middle income in 1990 and the CO2 emissions (% of total fuel combustion) of Angola in 1994?
Offer a terse response. -3.32. What is the difference between the CO2 emissions (% of total fuel combustion) in Low & middle income in 1990 and the CO2 emissions (% of total fuel combustion) in Ecuador in 1994?
Provide a short and direct response. 1.59. What is the difference between the CO2 emissions (% of total fuel combustion) in Low & middle income in 1990 and the CO2 emissions (% of total fuel combustion) in Kenya in 1994?
Your answer should be compact. 1.24. What is the difference between the CO2 emissions (% of total fuel combustion) in Angola in 1990 and the CO2 emissions (% of total fuel combustion) in Ecuador in 1994?
Offer a very short reply. 6.23. What is the difference between the CO2 emissions (% of total fuel combustion) in Angola in 1990 and the CO2 emissions (% of total fuel combustion) in Kenya in 1994?
Your answer should be compact. 5.88. What is the difference between the CO2 emissions (% of total fuel combustion) of Ecuador in 1990 and the CO2 emissions (% of total fuel combustion) of Kenya in 1994?
Provide a succinct answer. -0.41. What is the difference between the CO2 emissions (% of total fuel combustion) of Low & middle income in 1991 and the CO2 emissions (% of total fuel combustion) of Angola in 1992?
Keep it short and to the point. -4.32. What is the difference between the CO2 emissions (% of total fuel combustion) of Low & middle income in 1991 and the CO2 emissions (% of total fuel combustion) of Ecuador in 1992?
Keep it short and to the point. 1.73. What is the difference between the CO2 emissions (% of total fuel combustion) of Low & middle income in 1991 and the CO2 emissions (% of total fuel combustion) of Kenya in 1992?
Offer a terse response. 0.89. What is the difference between the CO2 emissions (% of total fuel combustion) of Angola in 1991 and the CO2 emissions (% of total fuel combustion) of Ecuador in 1992?
Offer a terse response. 7.03. What is the difference between the CO2 emissions (% of total fuel combustion) of Angola in 1991 and the CO2 emissions (% of total fuel combustion) of Kenya in 1992?
Provide a short and direct response. 6.19. What is the difference between the CO2 emissions (% of total fuel combustion) in Ecuador in 1991 and the CO2 emissions (% of total fuel combustion) in Kenya in 1992?
Your response must be concise. -0.64. What is the difference between the CO2 emissions (% of total fuel combustion) in Low & middle income in 1991 and the CO2 emissions (% of total fuel combustion) in Angola in 1993?
Provide a succinct answer. -0.9. What is the difference between the CO2 emissions (% of total fuel combustion) of Low & middle income in 1991 and the CO2 emissions (% of total fuel combustion) of Ecuador in 1993?
Make the answer very short. 1.27. What is the difference between the CO2 emissions (% of total fuel combustion) of Low & middle income in 1991 and the CO2 emissions (% of total fuel combustion) of Kenya in 1993?
Ensure brevity in your answer.  1.56. What is the difference between the CO2 emissions (% of total fuel combustion) of Angola in 1991 and the CO2 emissions (% of total fuel combustion) of Ecuador in 1993?
Give a very brief answer. 6.57. What is the difference between the CO2 emissions (% of total fuel combustion) of Angola in 1991 and the CO2 emissions (% of total fuel combustion) of Kenya in 1993?
Your answer should be compact. 6.87. What is the difference between the CO2 emissions (% of total fuel combustion) in Ecuador in 1991 and the CO2 emissions (% of total fuel combustion) in Kenya in 1993?
Your answer should be compact. 0.03. What is the difference between the CO2 emissions (% of total fuel combustion) of Low & middle income in 1991 and the CO2 emissions (% of total fuel combustion) of Angola in 1994?
Provide a succinct answer. -3.63. What is the difference between the CO2 emissions (% of total fuel combustion) of Low & middle income in 1991 and the CO2 emissions (% of total fuel combustion) of Ecuador in 1994?
Ensure brevity in your answer.  1.28. What is the difference between the CO2 emissions (% of total fuel combustion) in Low & middle income in 1991 and the CO2 emissions (% of total fuel combustion) in Kenya in 1994?
Keep it short and to the point. 0.93. What is the difference between the CO2 emissions (% of total fuel combustion) of Angola in 1991 and the CO2 emissions (% of total fuel combustion) of Ecuador in 1994?
Keep it short and to the point. 6.58. What is the difference between the CO2 emissions (% of total fuel combustion) in Angola in 1991 and the CO2 emissions (% of total fuel combustion) in Kenya in 1994?
Provide a succinct answer. 6.23. What is the difference between the CO2 emissions (% of total fuel combustion) in Ecuador in 1991 and the CO2 emissions (% of total fuel combustion) in Kenya in 1994?
Your response must be concise. -0.6. What is the difference between the CO2 emissions (% of total fuel combustion) in Low & middle income in 1992 and the CO2 emissions (% of total fuel combustion) in Angola in 1993?
Ensure brevity in your answer.  -1.07. What is the difference between the CO2 emissions (% of total fuel combustion) of Low & middle income in 1992 and the CO2 emissions (% of total fuel combustion) of Ecuador in 1993?
Your answer should be very brief. 1.1. What is the difference between the CO2 emissions (% of total fuel combustion) of Low & middle income in 1992 and the CO2 emissions (% of total fuel combustion) of Kenya in 1993?
Ensure brevity in your answer.  1.39. What is the difference between the CO2 emissions (% of total fuel combustion) of Angola in 1992 and the CO2 emissions (% of total fuel combustion) of Ecuador in 1993?
Your answer should be very brief. 5.59. What is the difference between the CO2 emissions (% of total fuel combustion) of Angola in 1992 and the CO2 emissions (% of total fuel combustion) of Kenya in 1993?
Keep it short and to the point. 5.88. What is the difference between the CO2 emissions (% of total fuel combustion) in Ecuador in 1992 and the CO2 emissions (% of total fuel combustion) in Kenya in 1993?
Your answer should be very brief. -0.16. What is the difference between the CO2 emissions (% of total fuel combustion) of Low & middle income in 1992 and the CO2 emissions (% of total fuel combustion) of Angola in 1994?
Offer a terse response. -3.8. What is the difference between the CO2 emissions (% of total fuel combustion) of Low & middle income in 1992 and the CO2 emissions (% of total fuel combustion) of Ecuador in 1994?
Keep it short and to the point. 1.11. What is the difference between the CO2 emissions (% of total fuel combustion) in Low & middle income in 1992 and the CO2 emissions (% of total fuel combustion) in Kenya in 1994?
Keep it short and to the point. 0.76. What is the difference between the CO2 emissions (% of total fuel combustion) of Angola in 1992 and the CO2 emissions (% of total fuel combustion) of Ecuador in 1994?
Your answer should be compact. 5.6. What is the difference between the CO2 emissions (% of total fuel combustion) in Angola in 1992 and the CO2 emissions (% of total fuel combustion) in Kenya in 1994?
Your response must be concise. 5.25. What is the difference between the CO2 emissions (% of total fuel combustion) in Ecuador in 1992 and the CO2 emissions (% of total fuel combustion) in Kenya in 1994?
Provide a succinct answer. -0.8. What is the difference between the CO2 emissions (% of total fuel combustion) in Low & middle income in 1993 and the CO2 emissions (% of total fuel combustion) in Angola in 1994?
Your answer should be very brief. -3.73. What is the difference between the CO2 emissions (% of total fuel combustion) of Low & middle income in 1993 and the CO2 emissions (% of total fuel combustion) of Ecuador in 1994?
Your answer should be very brief. 1.17. What is the difference between the CO2 emissions (% of total fuel combustion) of Low & middle income in 1993 and the CO2 emissions (% of total fuel combustion) of Kenya in 1994?
Provide a succinct answer. 0.82. What is the difference between the CO2 emissions (% of total fuel combustion) in Angola in 1993 and the CO2 emissions (% of total fuel combustion) in Ecuador in 1994?
Your answer should be compact. 2.18. What is the difference between the CO2 emissions (% of total fuel combustion) in Angola in 1993 and the CO2 emissions (% of total fuel combustion) in Kenya in 1994?
Keep it short and to the point. 1.83. What is the difference between the CO2 emissions (% of total fuel combustion) of Ecuador in 1993 and the CO2 emissions (% of total fuel combustion) of Kenya in 1994?
Give a very brief answer. -0.34. What is the average CO2 emissions (% of total fuel combustion) in Low & middle income per year?
Give a very brief answer. 11.46. What is the average CO2 emissions (% of total fuel combustion) in Angola per year?
Give a very brief answer. 16.57. What is the average CO2 emissions (% of total fuel combustion) of Ecuador per year?
Provide a short and direct response. 10.1. What is the average CO2 emissions (% of total fuel combustion) of Kenya per year?
Your answer should be very brief. 11.55. In the year 1987, what is the difference between the CO2 emissions (% of total fuel combustion) of Low & middle income and CO2 emissions (% of total fuel combustion) of Angola?
Offer a very short reply. -6.41. In the year 1987, what is the difference between the CO2 emissions (% of total fuel combustion) of Low & middle income and CO2 emissions (% of total fuel combustion) of Ecuador?
Your answer should be very brief. 2.51. In the year 1987, what is the difference between the CO2 emissions (% of total fuel combustion) in Low & middle income and CO2 emissions (% of total fuel combustion) in Kenya?
Your answer should be very brief. 1.04. In the year 1987, what is the difference between the CO2 emissions (% of total fuel combustion) of Angola and CO2 emissions (% of total fuel combustion) of Ecuador?
Provide a short and direct response. 8.92. In the year 1987, what is the difference between the CO2 emissions (% of total fuel combustion) in Angola and CO2 emissions (% of total fuel combustion) in Kenya?
Your response must be concise. 7.46. In the year 1987, what is the difference between the CO2 emissions (% of total fuel combustion) of Ecuador and CO2 emissions (% of total fuel combustion) of Kenya?
Provide a short and direct response. -1.47. In the year 1988, what is the difference between the CO2 emissions (% of total fuel combustion) of Low & middle income and CO2 emissions (% of total fuel combustion) of Angola?
Offer a very short reply. -7.67. In the year 1988, what is the difference between the CO2 emissions (% of total fuel combustion) in Low & middle income and CO2 emissions (% of total fuel combustion) in Ecuador?
Provide a succinct answer. 1.88. In the year 1988, what is the difference between the CO2 emissions (% of total fuel combustion) of Low & middle income and CO2 emissions (% of total fuel combustion) of Kenya?
Ensure brevity in your answer.  -1.91. In the year 1988, what is the difference between the CO2 emissions (% of total fuel combustion) in Angola and CO2 emissions (% of total fuel combustion) in Ecuador?
Your answer should be compact. 9.55. In the year 1988, what is the difference between the CO2 emissions (% of total fuel combustion) in Angola and CO2 emissions (% of total fuel combustion) in Kenya?
Your response must be concise. 5.76. In the year 1988, what is the difference between the CO2 emissions (% of total fuel combustion) in Ecuador and CO2 emissions (% of total fuel combustion) in Kenya?
Give a very brief answer. -3.79. In the year 1989, what is the difference between the CO2 emissions (% of total fuel combustion) of Low & middle income and CO2 emissions (% of total fuel combustion) of Angola?
Give a very brief answer. -7.33. In the year 1989, what is the difference between the CO2 emissions (% of total fuel combustion) in Low & middle income and CO2 emissions (% of total fuel combustion) in Ecuador?
Keep it short and to the point. -0.29. In the year 1989, what is the difference between the CO2 emissions (% of total fuel combustion) in Low & middle income and CO2 emissions (% of total fuel combustion) in Kenya?
Your answer should be compact. -3.03. In the year 1989, what is the difference between the CO2 emissions (% of total fuel combustion) of Angola and CO2 emissions (% of total fuel combustion) of Ecuador?
Provide a succinct answer. 7.04. In the year 1989, what is the difference between the CO2 emissions (% of total fuel combustion) in Angola and CO2 emissions (% of total fuel combustion) in Kenya?
Your answer should be compact. 4.3. In the year 1989, what is the difference between the CO2 emissions (% of total fuel combustion) in Ecuador and CO2 emissions (% of total fuel combustion) in Kenya?
Your answer should be very brief. -2.74. In the year 1990, what is the difference between the CO2 emissions (% of total fuel combustion) in Low & middle income and CO2 emissions (% of total fuel combustion) in Angola?
Make the answer very short. -4.64. In the year 1990, what is the difference between the CO2 emissions (% of total fuel combustion) in Low & middle income and CO2 emissions (% of total fuel combustion) in Ecuador?
Keep it short and to the point. 1.65. In the year 1990, what is the difference between the CO2 emissions (% of total fuel combustion) of Low & middle income and CO2 emissions (% of total fuel combustion) of Kenya?
Make the answer very short. 0.18. In the year 1990, what is the difference between the CO2 emissions (% of total fuel combustion) in Angola and CO2 emissions (% of total fuel combustion) in Ecuador?
Provide a succinct answer. 6.29. In the year 1990, what is the difference between the CO2 emissions (% of total fuel combustion) of Angola and CO2 emissions (% of total fuel combustion) of Kenya?
Offer a terse response. 4.82. In the year 1990, what is the difference between the CO2 emissions (% of total fuel combustion) of Ecuador and CO2 emissions (% of total fuel combustion) of Kenya?
Your answer should be compact. -1.47. In the year 1991, what is the difference between the CO2 emissions (% of total fuel combustion) of Low & middle income and CO2 emissions (% of total fuel combustion) of Angola?
Offer a terse response. -5.3. In the year 1991, what is the difference between the CO2 emissions (% of total fuel combustion) of Low & middle income and CO2 emissions (% of total fuel combustion) of Ecuador?
Offer a terse response. 1.53. In the year 1991, what is the difference between the CO2 emissions (% of total fuel combustion) of Low & middle income and CO2 emissions (% of total fuel combustion) of Kenya?
Provide a succinct answer. 0.25. In the year 1991, what is the difference between the CO2 emissions (% of total fuel combustion) of Angola and CO2 emissions (% of total fuel combustion) of Ecuador?
Your response must be concise. 6.83. In the year 1991, what is the difference between the CO2 emissions (% of total fuel combustion) in Angola and CO2 emissions (% of total fuel combustion) in Kenya?
Offer a very short reply. 5.55. In the year 1991, what is the difference between the CO2 emissions (% of total fuel combustion) of Ecuador and CO2 emissions (% of total fuel combustion) of Kenya?
Keep it short and to the point. -1.28. In the year 1992, what is the difference between the CO2 emissions (% of total fuel combustion) in Low & middle income and CO2 emissions (% of total fuel combustion) in Angola?
Your response must be concise. -4.49. In the year 1992, what is the difference between the CO2 emissions (% of total fuel combustion) in Low & middle income and CO2 emissions (% of total fuel combustion) in Ecuador?
Your response must be concise. 1.56. In the year 1992, what is the difference between the CO2 emissions (% of total fuel combustion) in Low & middle income and CO2 emissions (% of total fuel combustion) in Kenya?
Provide a succinct answer. 0.72. In the year 1992, what is the difference between the CO2 emissions (% of total fuel combustion) of Angola and CO2 emissions (% of total fuel combustion) of Ecuador?
Offer a terse response. 6.05. In the year 1992, what is the difference between the CO2 emissions (% of total fuel combustion) of Angola and CO2 emissions (% of total fuel combustion) of Kenya?
Your answer should be compact. 5.21. In the year 1992, what is the difference between the CO2 emissions (% of total fuel combustion) of Ecuador and CO2 emissions (% of total fuel combustion) of Kenya?
Your answer should be very brief. -0.84. In the year 1993, what is the difference between the CO2 emissions (% of total fuel combustion) of Low & middle income and CO2 emissions (% of total fuel combustion) of Angola?
Provide a short and direct response. -1. In the year 1993, what is the difference between the CO2 emissions (% of total fuel combustion) in Low & middle income and CO2 emissions (% of total fuel combustion) in Ecuador?
Provide a succinct answer. 1.17. In the year 1993, what is the difference between the CO2 emissions (% of total fuel combustion) in Low & middle income and CO2 emissions (% of total fuel combustion) in Kenya?
Make the answer very short. 1.46. In the year 1993, what is the difference between the CO2 emissions (% of total fuel combustion) of Angola and CO2 emissions (% of total fuel combustion) of Ecuador?
Give a very brief answer. 2.17. In the year 1993, what is the difference between the CO2 emissions (% of total fuel combustion) in Angola and CO2 emissions (% of total fuel combustion) in Kenya?
Your answer should be compact. 2.46. In the year 1993, what is the difference between the CO2 emissions (% of total fuel combustion) of Ecuador and CO2 emissions (% of total fuel combustion) of Kenya?
Your response must be concise. 0.29. In the year 1994, what is the difference between the CO2 emissions (% of total fuel combustion) in Low & middle income and CO2 emissions (% of total fuel combustion) in Angola?
Provide a succinct answer. -3.99. In the year 1994, what is the difference between the CO2 emissions (% of total fuel combustion) of Low & middle income and CO2 emissions (% of total fuel combustion) of Ecuador?
Ensure brevity in your answer.  0.91. In the year 1994, what is the difference between the CO2 emissions (% of total fuel combustion) of Low & middle income and CO2 emissions (% of total fuel combustion) of Kenya?
Your answer should be very brief. 0.56. In the year 1994, what is the difference between the CO2 emissions (% of total fuel combustion) of Angola and CO2 emissions (% of total fuel combustion) of Ecuador?
Offer a very short reply. 4.91. In the year 1994, what is the difference between the CO2 emissions (% of total fuel combustion) of Angola and CO2 emissions (% of total fuel combustion) of Kenya?
Give a very brief answer. 4.56. In the year 1994, what is the difference between the CO2 emissions (% of total fuel combustion) of Ecuador and CO2 emissions (% of total fuel combustion) of Kenya?
Your answer should be compact. -0.35. What is the ratio of the CO2 emissions (% of total fuel combustion) in Angola in 1987 to that in 1988?
Offer a very short reply. 0.93. What is the ratio of the CO2 emissions (% of total fuel combustion) in Ecuador in 1987 to that in 1988?
Provide a short and direct response. 0.93. What is the ratio of the CO2 emissions (% of total fuel combustion) of Kenya in 1987 to that in 1988?
Provide a short and direct response. 0.79. What is the ratio of the CO2 emissions (% of total fuel combustion) in Low & middle income in 1987 to that in 1989?
Offer a terse response. 1.01. What is the ratio of the CO2 emissions (% of total fuel combustion) of Angola in 1987 to that in 1989?
Make the answer very short. 0.96. What is the ratio of the CO2 emissions (% of total fuel combustion) of Ecuador in 1987 to that in 1989?
Provide a short and direct response. 0.79. What is the ratio of the CO2 emissions (% of total fuel combustion) in Kenya in 1987 to that in 1989?
Your answer should be compact. 0.75. What is the ratio of the CO2 emissions (% of total fuel combustion) in Low & middle income in 1987 to that in 1990?
Offer a terse response. 1.15. What is the ratio of the CO2 emissions (% of total fuel combustion) in Angola in 1987 to that in 1990?
Your answer should be compact. 1.22. What is the ratio of the CO2 emissions (% of total fuel combustion) in Ecuador in 1987 to that in 1990?
Make the answer very short. 1.09. What is the ratio of the CO2 emissions (% of total fuel combustion) in Kenya in 1987 to that in 1990?
Offer a terse response. 1.08. What is the ratio of the CO2 emissions (% of total fuel combustion) in Low & middle income in 1987 to that in 1991?
Offer a very short reply. 1.19. What is the ratio of the CO2 emissions (% of total fuel combustion) in Angola in 1987 to that in 1991?
Keep it short and to the point. 1.19. What is the ratio of the CO2 emissions (% of total fuel combustion) of Ecuador in 1987 to that in 1991?
Provide a short and direct response. 1.11. What is the ratio of the CO2 emissions (% of total fuel combustion) of Kenya in 1987 to that in 1991?
Provide a short and direct response. 1.12. What is the ratio of the CO2 emissions (% of total fuel combustion) of Low & middle income in 1987 to that in 1992?
Your response must be concise. 1.21. What is the ratio of the CO2 emissions (% of total fuel combustion) in Angola in 1987 to that in 1992?
Provide a succinct answer. 1.27. What is the ratio of the CO2 emissions (% of total fuel combustion) in Ecuador in 1987 to that in 1992?
Your answer should be compact. 1.14. What is the ratio of the CO2 emissions (% of total fuel combustion) of Kenya in 1987 to that in 1992?
Ensure brevity in your answer.  1.19. What is the ratio of the CO2 emissions (% of total fuel combustion) in Low & middle income in 1987 to that in 1993?
Ensure brevity in your answer.  1.2. What is the ratio of the CO2 emissions (% of total fuel combustion) in Angola in 1987 to that in 1993?
Your answer should be very brief. 1.65. What is the ratio of the CO2 emissions (% of total fuel combustion) in Ecuador in 1987 to that in 1993?
Ensure brevity in your answer.  1.08. What is the ratio of the CO2 emissions (% of total fuel combustion) of Kenya in 1987 to that in 1993?
Your answer should be very brief. 1.27. What is the ratio of the CO2 emissions (% of total fuel combustion) of Low & middle income in 1987 to that in 1994?
Make the answer very short. 1.23. What is the ratio of the CO2 emissions (% of total fuel combustion) in Angola in 1987 to that in 1994?
Give a very brief answer. 1.33. What is the ratio of the CO2 emissions (% of total fuel combustion) in Ecuador in 1987 to that in 1994?
Offer a terse response. 1.08. What is the ratio of the CO2 emissions (% of total fuel combustion) of Kenya in 1987 to that in 1994?
Offer a terse response. 1.19. What is the ratio of the CO2 emissions (% of total fuel combustion) of Low & middle income in 1988 to that in 1989?
Offer a terse response. 1.02. What is the ratio of the CO2 emissions (% of total fuel combustion) in Angola in 1988 to that in 1989?
Your response must be concise. 1.03. What is the ratio of the CO2 emissions (% of total fuel combustion) in Ecuador in 1988 to that in 1989?
Offer a terse response. 0.85. What is the ratio of the CO2 emissions (% of total fuel combustion) in Kenya in 1988 to that in 1989?
Offer a terse response. 0.95. What is the ratio of the CO2 emissions (% of total fuel combustion) in Low & middle income in 1988 to that in 1990?
Keep it short and to the point. 1.16. What is the ratio of the CO2 emissions (% of total fuel combustion) of Angola in 1988 to that in 1990?
Your answer should be compact. 1.31. What is the ratio of the CO2 emissions (% of total fuel combustion) in Ecuador in 1988 to that in 1990?
Provide a short and direct response. 1.17. What is the ratio of the CO2 emissions (% of total fuel combustion) of Kenya in 1988 to that in 1990?
Give a very brief answer. 1.36. What is the ratio of the CO2 emissions (% of total fuel combustion) of Low & middle income in 1988 to that in 1991?
Keep it short and to the point. 1.2. What is the ratio of the CO2 emissions (% of total fuel combustion) in Angola in 1988 to that in 1991?
Keep it short and to the point. 1.28. What is the ratio of the CO2 emissions (% of total fuel combustion) of Ecuador in 1988 to that in 1991?
Make the answer very short. 1.19. What is the ratio of the CO2 emissions (% of total fuel combustion) in Kenya in 1988 to that in 1991?
Provide a short and direct response. 1.41. What is the ratio of the CO2 emissions (% of total fuel combustion) of Low & middle income in 1988 to that in 1992?
Ensure brevity in your answer.  1.22. What is the ratio of the CO2 emissions (% of total fuel combustion) in Angola in 1988 to that in 1992?
Offer a terse response. 1.36. What is the ratio of the CO2 emissions (% of total fuel combustion) of Ecuador in 1988 to that in 1992?
Offer a terse response. 1.22. What is the ratio of the CO2 emissions (% of total fuel combustion) of Kenya in 1988 to that in 1992?
Provide a succinct answer. 1.5. What is the ratio of the CO2 emissions (% of total fuel combustion) of Low & middle income in 1988 to that in 1993?
Provide a short and direct response. 1.21. What is the ratio of the CO2 emissions (% of total fuel combustion) in Angola in 1988 to that in 1993?
Make the answer very short. 1.76. What is the ratio of the CO2 emissions (% of total fuel combustion) in Ecuador in 1988 to that in 1993?
Offer a very short reply. 1.16. What is the ratio of the CO2 emissions (% of total fuel combustion) of Kenya in 1988 to that in 1993?
Keep it short and to the point. 1.61. What is the ratio of the CO2 emissions (% of total fuel combustion) of Low & middle income in 1988 to that in 1994?
Your response must be concise. 1.24. What is the ratio of the CO2 emissions (% of total fuel combustion) in Angola in 1988 to that in 1994?
Provide a succinct answer. 1.43. What is the ratio of the CO2 emissions (% of total fuel combustion) in Ecuador in 1988 to that in 1994?
Offer a very short reply. 1.16. What is the ratio of the CO2 emissions (% of total fuel combustion) of Kenya in 1988 to that in 1994?
Your response must be concise. 1.5. What is the ratio of the CO2 emissions (% of total fuel combustion) in Low & middle income in 1989 to that in 1990?
Offer a very short reply. 1.14. What is the ratio of the CO2 emissions (% of total fuel combustion) in Angola in 1989 to that in 1990?
Provide a short and direct response. 1.27. What is the ratio of the CO2 emissions (% of total fuel combustion) of Ecuador in 1989 to that in 1990?
Offer a very short reply. 1.37. What is the ratio of the CO2 emissions (% of total fuel combustion) of Kenya in 1989 to that in 1990?
Ensure brevity in your answer.  1.44. What is the ratio of the CO2 emissions (% of total fuel combustion) in Low & middle income in 1989 to that in 1991?
Offer a terse response. 1.17. What is the ratio of the CO2 emissions (% of total fuel combustion) of Angola in 1989 to that in 1991?
Give a very brief answer. 1.24. What is the ratio of the CO2 emissions (% of total fuel combustion) of Ecuador in 1989 to that in 1991?
Provide a succinct answer. 1.4. What is the ratio of the CO2 emissions (% of total fuel combustion) of Kenya in 1989 to that in 1991?
Your answer should be very brief. 1.49. What is the ratio of the CO2 emissions (% of total fuel combustion) in Low & middle income in 1989 to that in 1992?
Make the answer very short. 1.19. What is the ratio of the CO2 emissions (% of total fuel combustion) of Angola in 1989 to that in 1992?
Give a very brief answer. 1.32. What is the ratio of the CO2 emissions (% of total fuel combustion) of Ecuador in 1989 to that in 1992?
Provide a short and direct response. 1.43. What is the ratio of the CO2 emissions (% of total fuel combustion) of Kenya in 1989 to that in 1992?
Your answer should be very brief. 1.58. What is the ratio of the CO2 emissions (% of total fuel combustion) in Low & middle income in 1989 to that in 1993?
Make the answer very short. 1.18. What is the ratio of the CO2 emissions (% of total fuel combustion) in Angola in 1989 to that in 1993?
Your answer should be compact. 1.71. What is the ratio of the CO2 emissions (% of total fuel combustion) in Ecuador in 1989 to that in 1993?
Provide a short and direct response. 1.36. What is the ratio of the CO2 emissions (% of total fuel combustion) in Kenya in 1989 to that in 1993?
Keep it short and to the point. 1.7. What is the ratio of the CO2 emissions (% of total fuel combustion) in Low & middle income in 1989 to that in 1994?
Provide a succinct answer. 1.21. What is the ratio of the CO2 emissions (% of total fuel combustion) of Angola in 1989 to that in 1994?
Your answer should be very brief. 1.39. What is the ratio of the CO2 emissions (% of total fuel combustion) in Ecuador in 1989 to that in 1994?
Keep it short and to the point. 1.36. What is the ratio of the CO2 emissions (% of total fuel combustion) of Kenya in 1989 to that in 1994?
Your response must be concise. 1.59. What is the ratio of the CO2 emissions (% of total fuel combustion) of Angola in 1990 to that in 1991?
Your answer should be compact. 0.98. What is the ratio of the CO2 emissions (% of total fuel combustion) in Ecuador in 1990 to that in 1991?
Provide a succinct answer. 1.02. What is the ratio of the CO2 emissions (% of total fuel combustion) of Kenya in 1990 to that in 1991?
Offer a terse response. 1.04. What is the ratio of the CO2 emissions (% of total fuel combustion) of Low & middle income in 1990 to that in 1992?
Offer a terse response. 1.05. What is the ratio of the CO2 emissions (% of total fuel combustion) in Angola in 1990 to that in 1992?
Offer a terse response. 1.04. What is the ratio of the CO2 emissions (% of total fuel combustion) of Ecuador in 1990 to that in 1992?
Your answer should be compact. 1.04. What is the ratio of the CO2 emissions (% of total fuel combustion) of Kenya in 1990 to that in 1992?
Your answer should be very brief. 1.1. What is the ratio of the CO2 emissions (% of total fuel combustion) in Low & middle income in 1990 to that in 1993?
Your answer should be very brief. 1.04. What is the ratio of the CO2 emissions (% of total fuel combustion) of Angola in 1990 to that in 1993?
Provide a succinct answer. 1.35. What is the ratio of the CO2 emissions (% of total fuel combustion) in Kenya in 1990 to that in 1993?
Your answer should be compact. 1.18. What is the ratio of the CO2 emissions (% of total fuel combustion) in Low & middle income in 1990 to that in 1994?
Your response must be concise. 1.06. What is the ratio of the CO2 emissions (% of total fuel combustion) in Angola in 1990 to that in 1994?
Give a very brief answer. 1.09. What is the ratio of the CO2 emissions (% of total fuel combustion) of Kenya in 1990 to that in 1994?
Ensure brevity in your answer.  1.11. What is the ratio of the CO2 emissions (% of total fuel combustion) in Low & middle income in 1991 to that in 1992?
Ensure brevity in your answer.  1.02. What is the ratio of the CO2 emissions (% of total fuel combustion) in Angola in 1991 to that in 1992?
Ensure brevity in your answer.  1.07. What is the ratio of the CO2 emissions (% of total fuel combustion) of Ecuador in 1991 to that in 1992?
Your response must be concise. 1.02. What is the ratio of the CO2 emissions (% of total fuel combustion) of Kenya in 1991 to that in 1992?
Keep it short and to the point. 1.06. What is the ratio of the CO2 emissions (% of total fuel combustion) of Low & middle income in 1991 to that in 1993?
Provide a short and direct response. 1.01. What is the ratio of the CO2 emissions (% of total fuel combustion) of Angola in 1991 to that in 1993?
Provide a succinct answer. 1.38. What is the ratio of the CO2 emissions (% of total fuel combustion) of Ecuador in 1991 to that in 1993?
Your answer should be very brief. 0.97. What is the ratio of the CO2 emissions (% of total fuel combustion) in Low & middle income in 1991 to that in 1994?
Offer a very short reply. 1.03. What is the ratio of the CO2 emissions (% of total fuel combustion) in Angola in 1991 to that in 1994?
Provide a succinct answer. 1.12. What is the ratio of the CO2 emissions (% of total fuel combustion) in Ecuador in 1991 to that in 1994?
Ensure brevity in your answer.  0.97. What is the ratio of the CO2 emissions (% of total fuel combustion) of Kenya in 1991 to that in 1994?
Your answer should be very brief. 1.07. What is the ratio of the CO2 emissions (% of total fuel combustion) in Angola in 1992 to that in 1993?
Your answer should be compact. 1.29. What is the ratio of the CO2 emissions (% of total fuel combustion) in Ecuador in 1992 to that in 1993?
Provide a short and direct response. 0.95. What is the ratio of the CO2 emissions (% of total fuel combustion) of Kenya in 1992 to that in 1993?
Your response must be concise. 1.07. What is the ratio of the CO2 emissions (% of total fuel combustion) of Low & middle income in 1992 to that in 1994?
Keep it short and to the point. 1.02. What is the ratio of the CO2 emissions (% of total fuel combustion) of Angola in 1992 to that in 1994?
Keep it short and to the point. 1.05. What is the ratio of the CO2 emissions (% of total fuel combustion) in Ecuador in 1992 to that in 1994?
Ensure brevity in your answer.  0.95. What is the ratio of the CO2 emissions (% of total fuel combustion) in Low & middle income in 1993 to that in 1994?
Offer a very short reply. 1.02. What is the ratio of the CO2 emissions (% of total fuel combustion) in Angola in 1993 to that in 1994?
Give a very brief answer. 0.81. What is the ratio of the CO2 emissions (% of total fuel combustion) of Ecuador in 1993 to that in 1994?
Provide a short and direct response. 1. What is the ratio of the CO2 emissions (% of total fuel combustion) of Kenya in 1993 to that in 1994?
Give a very brief answer. 0.94. What is the difference between the highest and the second highest CO2 emissions (% of total fuel combustion) of Low & middle income?
Ensure brevity in your answer.  0.11. What is the difference between the highest and the second highest CO2 emissions (% of total fuel combustion) in Angola?
Keep it short and to the point. 0.6. What is the difference between the highest and the second highest CO2 emissions (% of total fuel combustion) in Ecuador?
Your response must be concise. 1.91. What is the difference between the highest and the second highest CO2 emissions (% of total fuel combustion) in Kenya?
Your response must be concise. 0.85. What is the difference between the highest and the lowest CO2 emissions (% of total fuel combustion) in Low & middle income?
Provide a succinct answer. 2.48. What is the difference between the highest and the lowest CO2 emissions (% of total fuel combustion) in Angola?
Provide a succinct answer. 8.89. What is the difference between the highest and the lowest CO2 emissions (% of total fuel combustion) in Ecuador?
Your answer should be very brief. 3.87. What is the difference between the highest and the lowest CO2 emissions (% of total fuel combustion) of Kenya?
Make the answer very short. 6.45. 